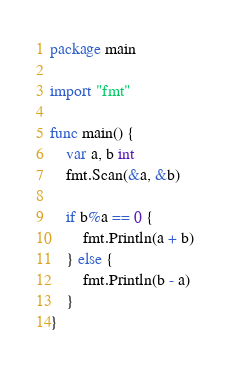Convert code to text. <code><loc_0><loc_0><loc_500><loc_500><_Go_>package main

import "fmt"

func main() {
	var a, b int
	fmt.Scan(&a, &b)

	if b%a == 0 {
		fmt.Println(a + b)
	} else {
		fmt.Println(b - a)
	}
}
</code> 